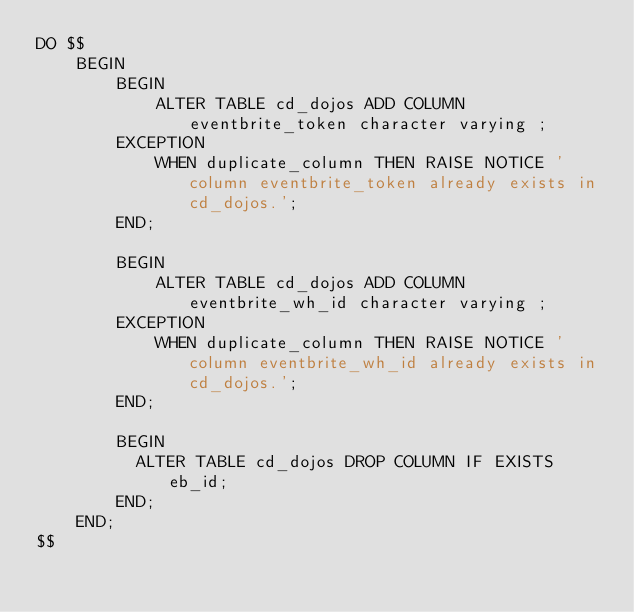<code> <loc_0><loc_0><loc_500><loc_500><_SQL_>DO $$
    BEGIN
        BEGIN
            ALTER TABLE cd_dojos ADD COLUMN eventbrite_token character varying ;
        EXCEPTION
            WHEN duplicate_column THEN RAISE NOTICE 'column eventbrite_token already exists in cd_dojos.';
        END;

        BEGIN
            ALTER TABLE cd_dojos ADD COLUMN eventbrite_wh_id character varying ;
        EXCEPTION
            WHEN duplicate_column THEN RAISE NOTICE 'column eventbrite_wh_id already exists in cd_dojos.';
        END;

        BEGIN
          ALTER TABLE cd_dojos DROP COLUMN IF EXISTS eb_id;
        END;
    END;
$$
</code> 